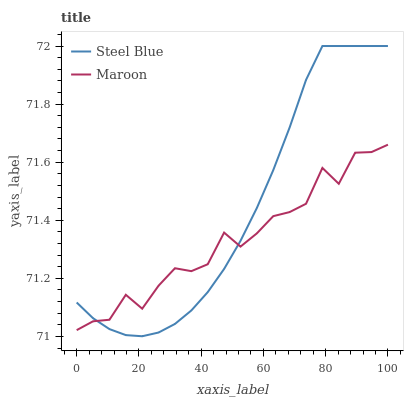Does Maroon have the minimum area under the curve?
Answer yes or no. Yes. Does Steel Blue have the maximum area under the curve?
Answer yes or no. Yes. Does Maroon have the maximum area under the curve?
Answer yes or no. No. Is Steel Blue the smoothest?
Answer yes or no. Yes. Is Maroon the roughest?
Answer yes or no. Yes. Is Maroon the smoothest?
Answer yes or no. No. Does Steel Blue have the lowest value?
Answer yes or no. Yes. Does Maroon have the lowest value?
Answer yes or no. No. Does Steel Blue have the highest value?
Answer yes or no. Yes. Does Maroon have the highest value?
Answer yes or no. No. Does Steel Blue intersect Maroon?
Answer yes or no. Yes. Is Steel Blue less than Maroon?
Answer yes or no. No. Is Steel Blue greater than Maroon?
Answer yes or no. No. 